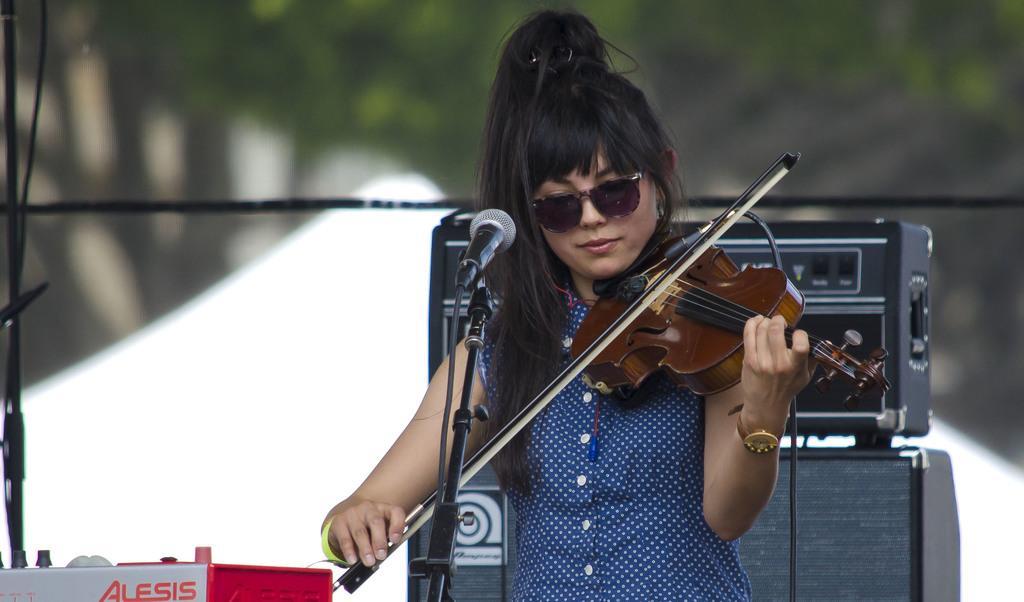Please provide a concise description of this image. A woman is playing a violin with a mic in front of her. She is wearing goggles. There is a music system and speaker behind her. 